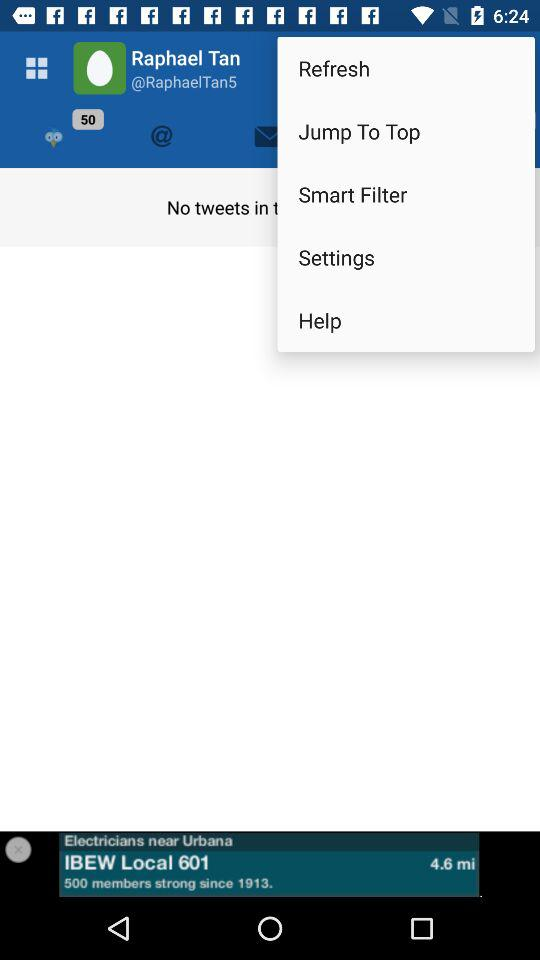What is the user name? The user name is Raphael Tan. 